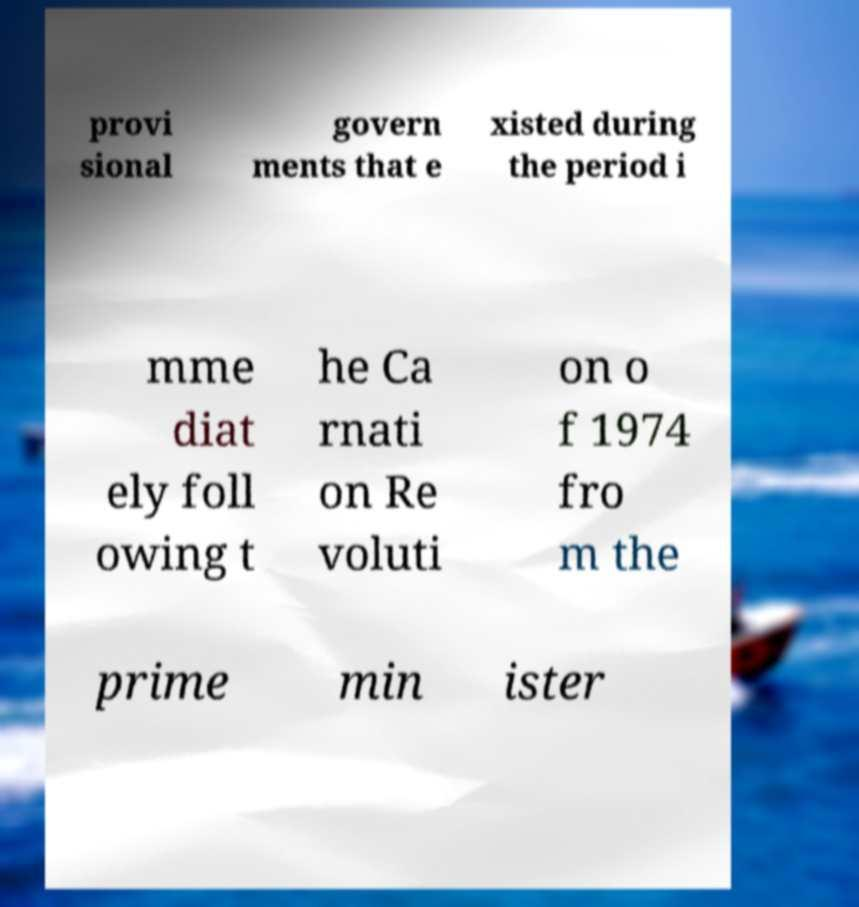For documentation purposes, I need the text within this image transcribed. Could you provide that? provi sional govern ments that e xisted during the period i mme diat ely foll owing t he Ca rnati on Re voluti on o f 1974 fro m the prime min ister 